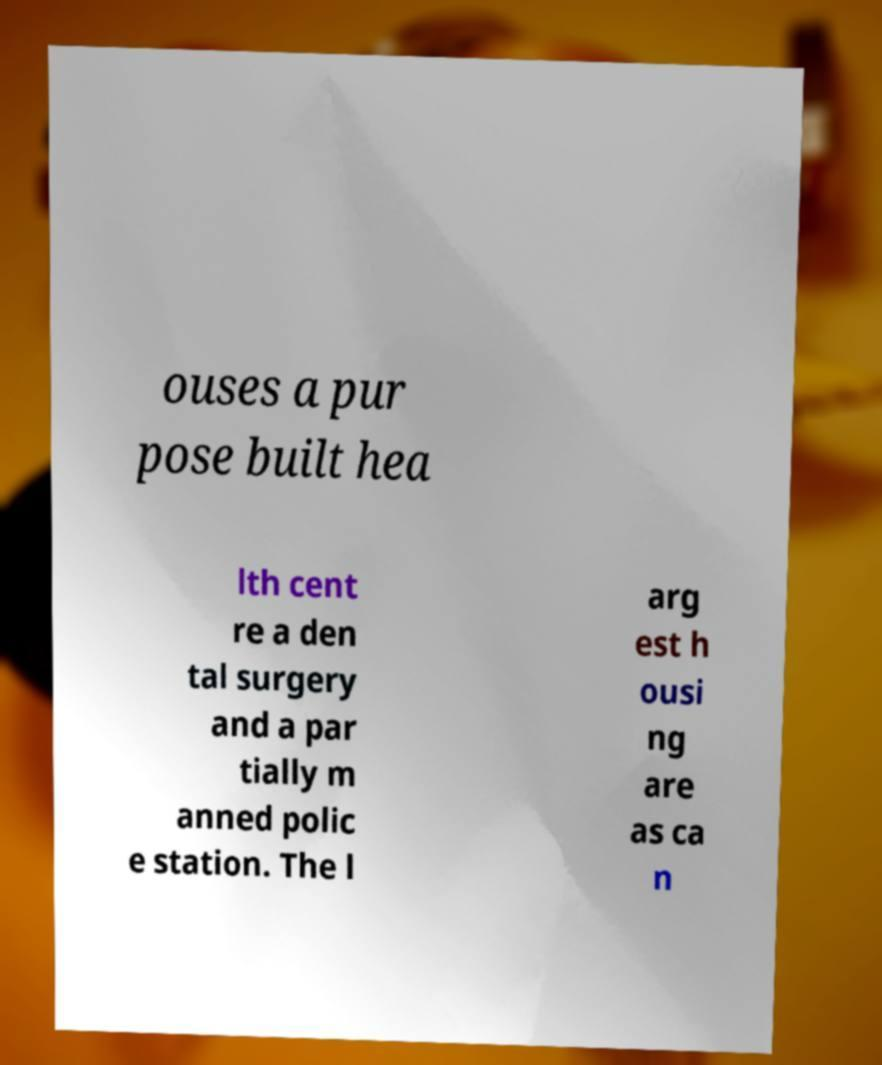I need the written content from this picture converted into text. Can you do that? ouses a pur pose built hea lth cent re a den tal surgery and a par tially m anned polic e station. The l arg est h ousi ng are as ca n 